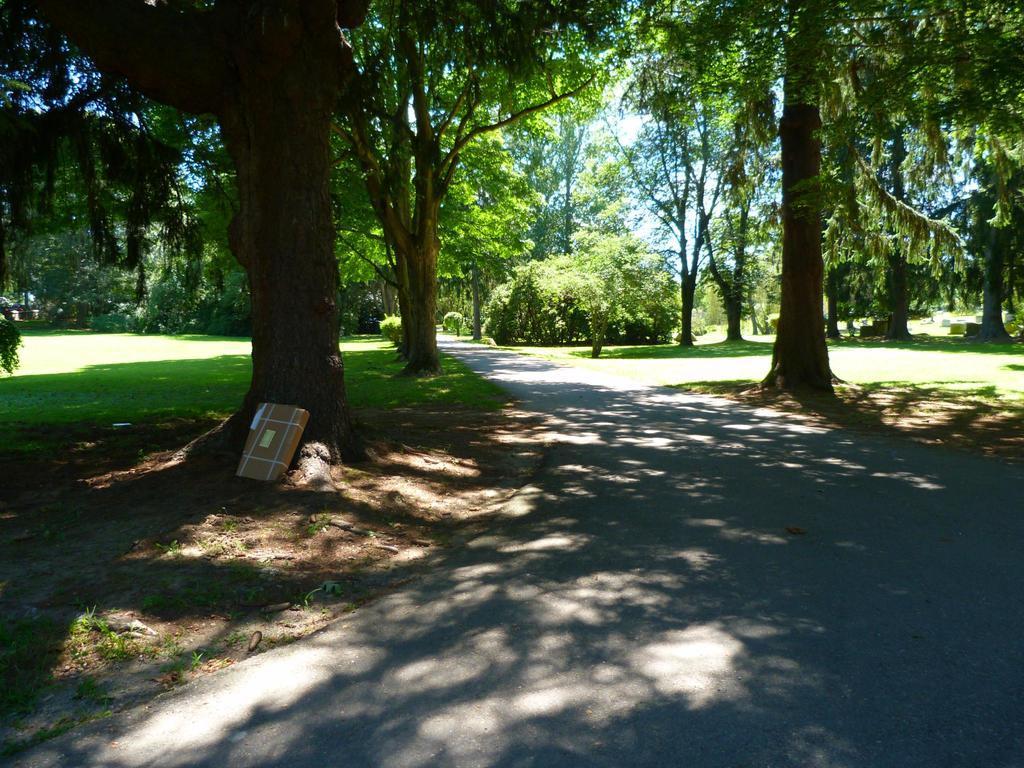How would you summarize this image in a sentence or two? In this image we can see a road, trees, grass and sky. 